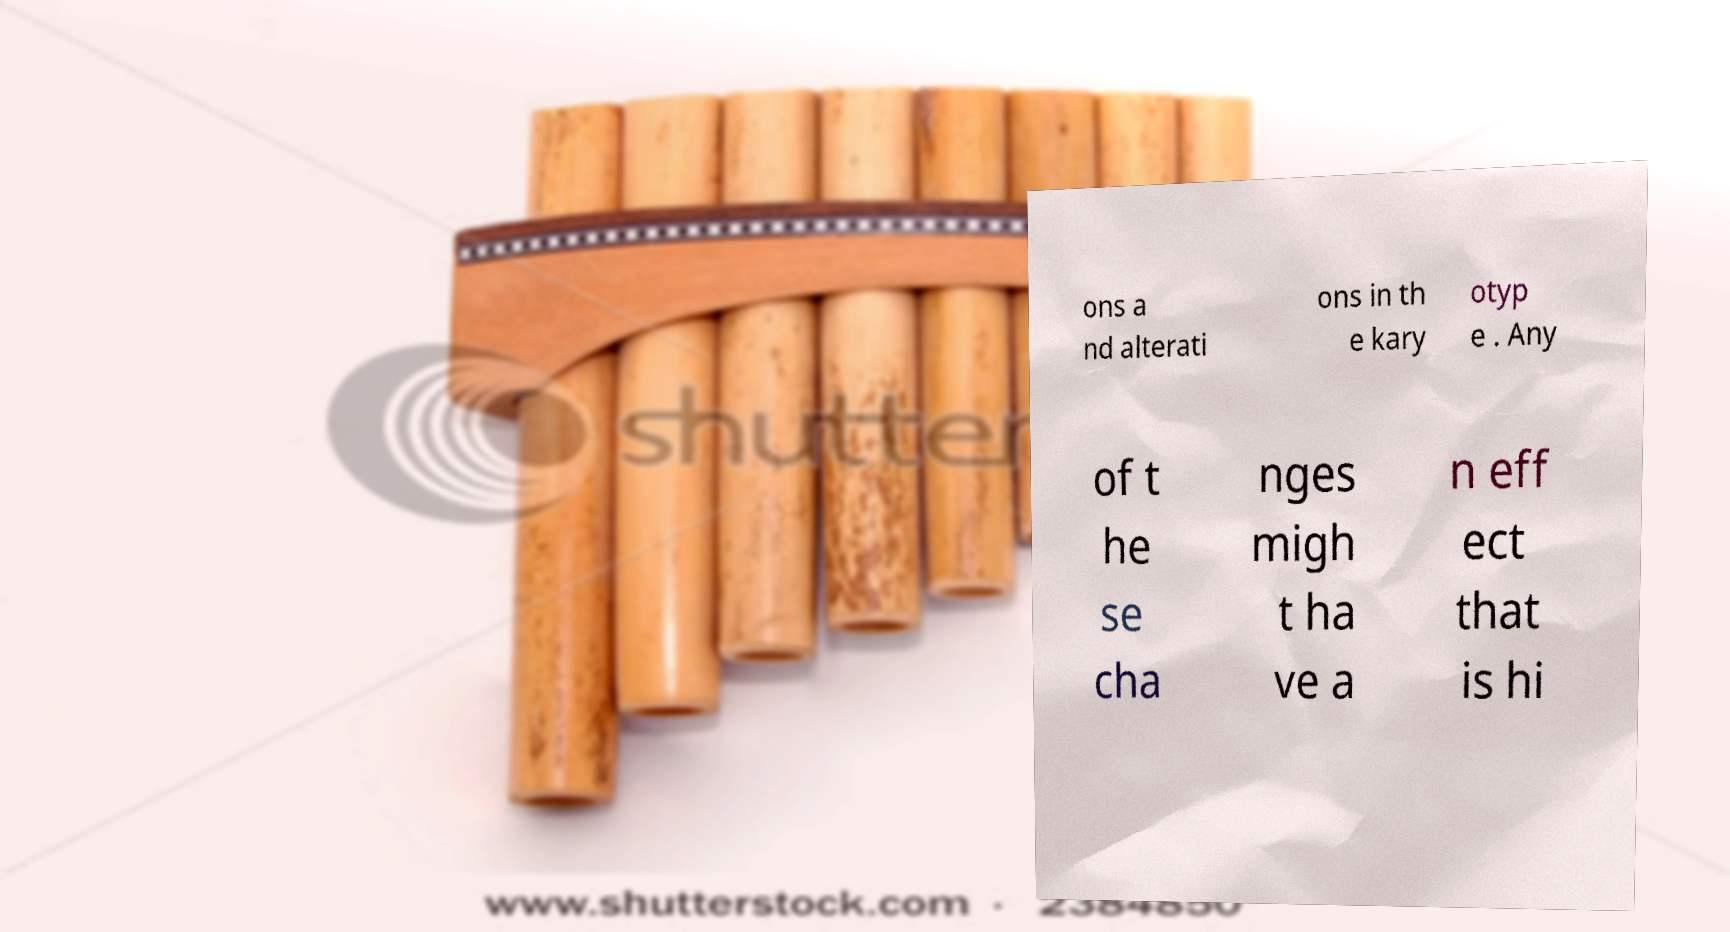There's text embedded in this image that I need extracted. Can you transcribe it verbatim? ons a nd alterati ons in th e kary otyp e . Any of t he se cha nges migh t ha ve a n eff ect that is hi 